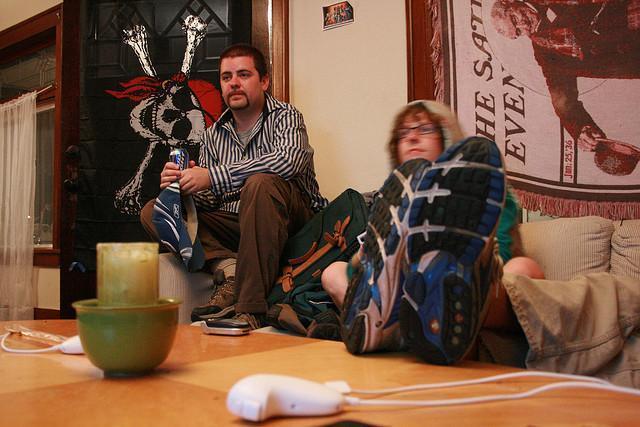How many animals are seen?
Give a very brief answer. 0. How many people are in the picture?
Give a very brief answer. 2. 